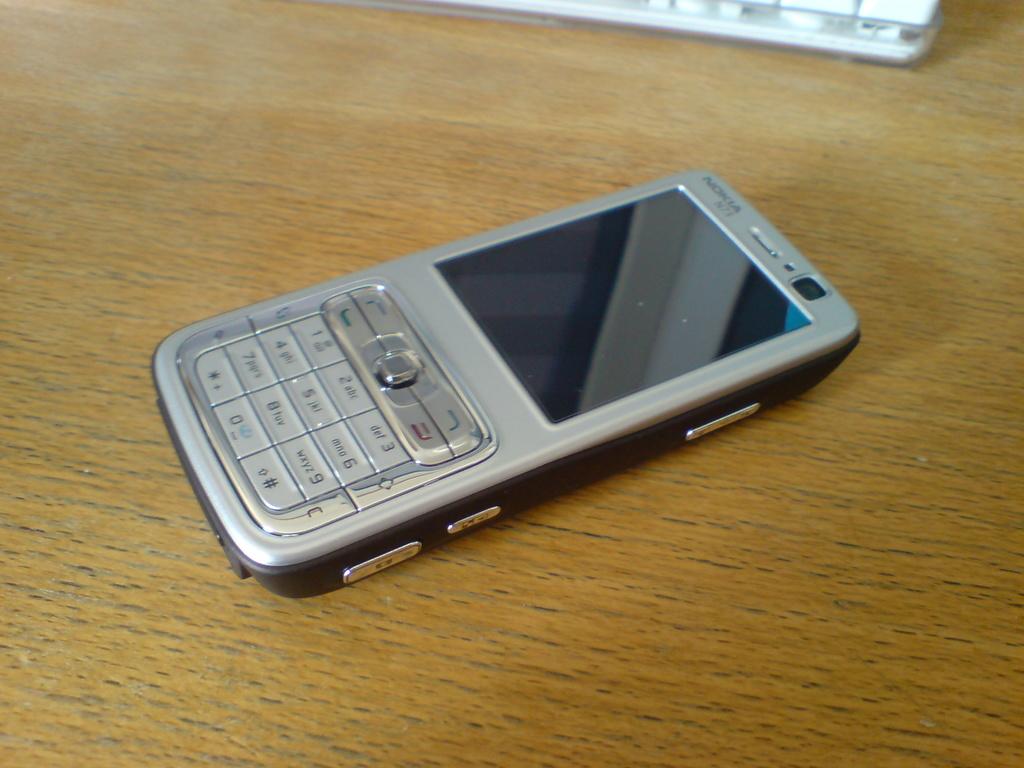What is the label of one of the buttons on the phone?
Keep it short and to the point. Def 3. 